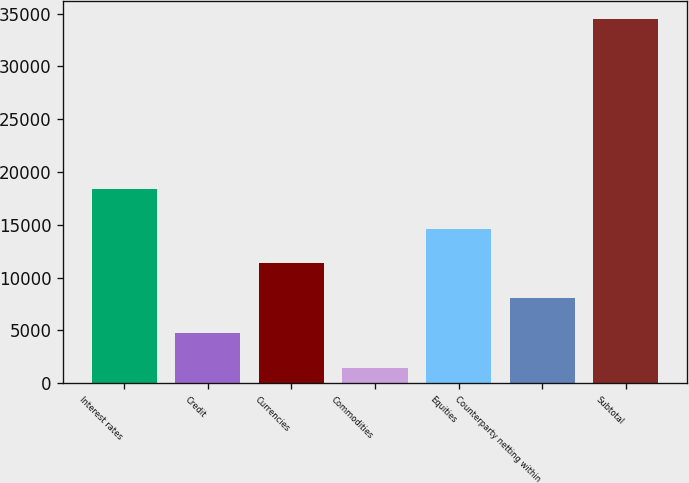<chart> <loc_0><loc_0><loc_500><loc_500><bar_chart><fcel>Interest rates<fcel>Credit<fcel>Currencies<fcel>Commodities<fcel>Equities<fcel>Counterparty netting within<fcel>Subtotal<nl><fcel>18376<fcel>4721.2<fcel>11333.6<fcel>1415<fcel>14639.8<fcel>8027.4<fcel>34477<nl></chart> 